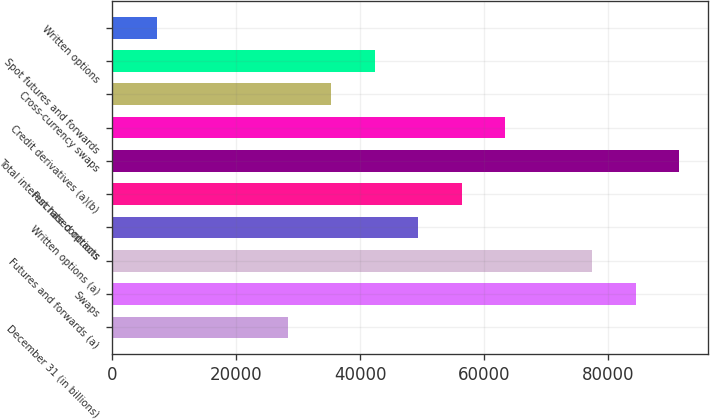<chart> <loc_0><loc_0><loc_500><loc_500><bar_chart><fcel>December 31 (in billions)<fcel>Swaps<fcel>Futures and forwards (a)<fcel>Written options (a)<fcel>Purchased options<fcel>Total interest rate contracts<fcel>Credit derivatives (a)(b)<fcel>Cross-currency swaps<fcel>Spot futures and forwards<fcel>Written options<nl><fcel>28277.4<fcel>84458.2<fcel>77435.6<fcel>49345.2<fcel>56367.8<fcel>91480.8<fcel>63390.4<fcel>35300<fcel>42322.6<fcel>7209.6<nl></chart> 